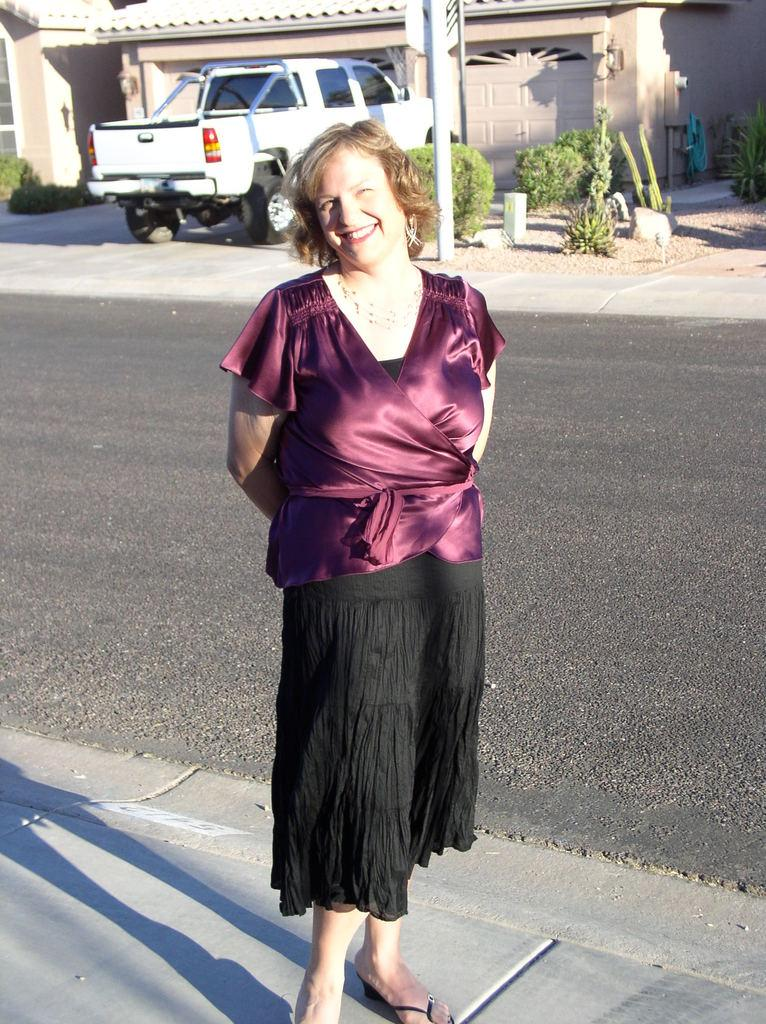Who is present in the image? There is a woman in the image. What is the woman doing in the image? The woman is watching and smiling in the image. Where is the woman standing in the image? The woman is standing on a walkway in the image. What can be seen in the background of the image? In the background of the image, there is a road, at least one vehicle, a house, walls, plants, poles, and other objects. What type of bear can be seen playing with a comb in the image? There is no bear or comb present in the image. 